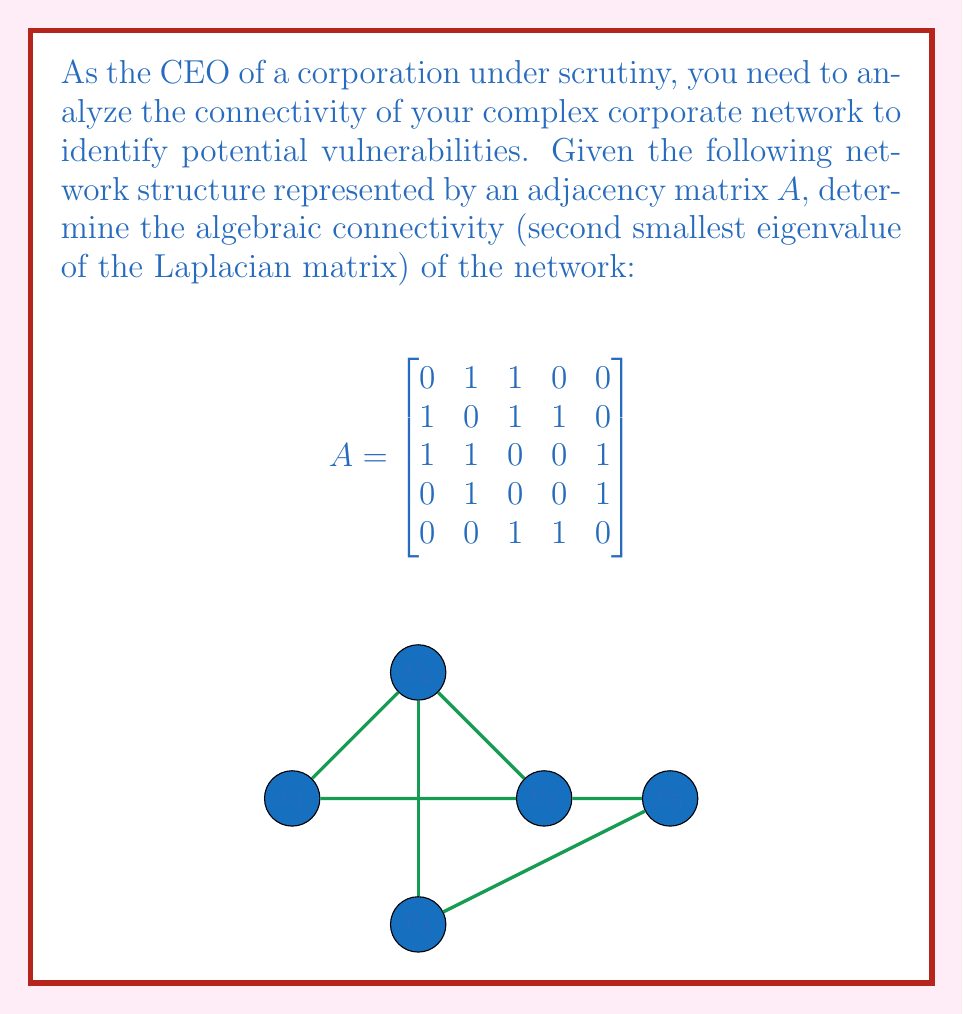Help me with this question. To find the algebraic connectivity, we need to follow these steps:

1) First, calculate the degree matrix D:
   $$D = \begin{bmatrix}
   2 & 0 & 0 & 0 & 0 \\
   0 & 3 & 0 & 0 & 0 \\
   0 & 0 & 3 & 0 & 0 \\
   0 & 0 & 0 & 2 & 0 \\
   0 & 0 & 0 & 0 & 2
   \end{bmatrix}$$

2) Calculate the Laplacian matrix L = D - A:
   $$L = \begin{bmatrix}
   2 & -1 & -1 & 0 & 0 \\
   -1 & 3 & -1 & -1 & 0 \\
   -1 & -1 & 3 & 0 & -1 \\
   0 & -1 & 0 & 2 & -1 \\
   0 & 0 & -1 & -1 & 2
   \end{bmatrix}$$

3) Find the eigenvalues of L. The characteristic equation is:
   $$\det(L - \lambda I) = 0$$

4) Solving this equation (using a computer algebra system due to complexity) gives the eigenvalues:
   $$\lambda_1 = 0$$
   $$\lambda_2 \approx 0.5858$$
   $$\lambda_3 \approx 2.0000$$
   $$\lambda_4 \approx 3.0000$$
   $$\lambda_5 \approx 4.4142$$

5) The algebraic connectivity is the second smallest eigenvalue, which is $\lambda_2 \approx 0.5858$.
Answer: $0.5858$ 